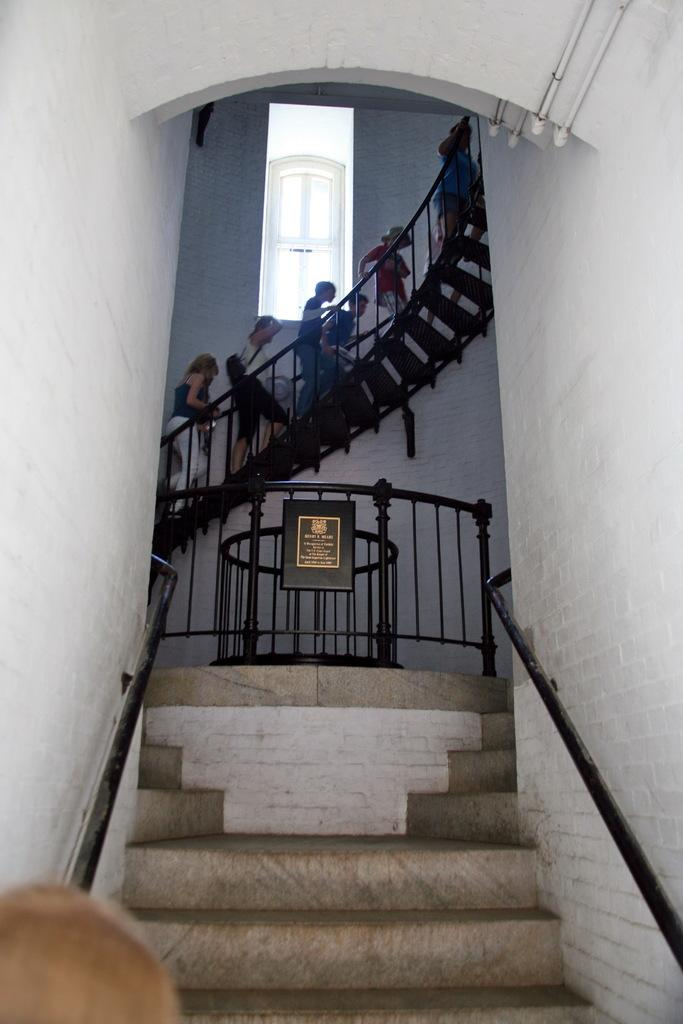What can be seen in the image that people use to move between different levels? There are stairs in the image that people are using to climb. What is the large, flat object in the image that can be used for writing or displaying information? There is a black color board in the image. What is visible in the background of the image? There is a wall in the background of the image. What are the people in the image doing? People are climbing the stairs in the image. What feature in the image allows natural light to enter the space? There is a window in the image. Can you see an owl perched on the color board in the image? No, there is no owl present in the image. Are there any bubbles floating around the people climbing the stairs in the image? No, there are no bubbles visible in the image. 